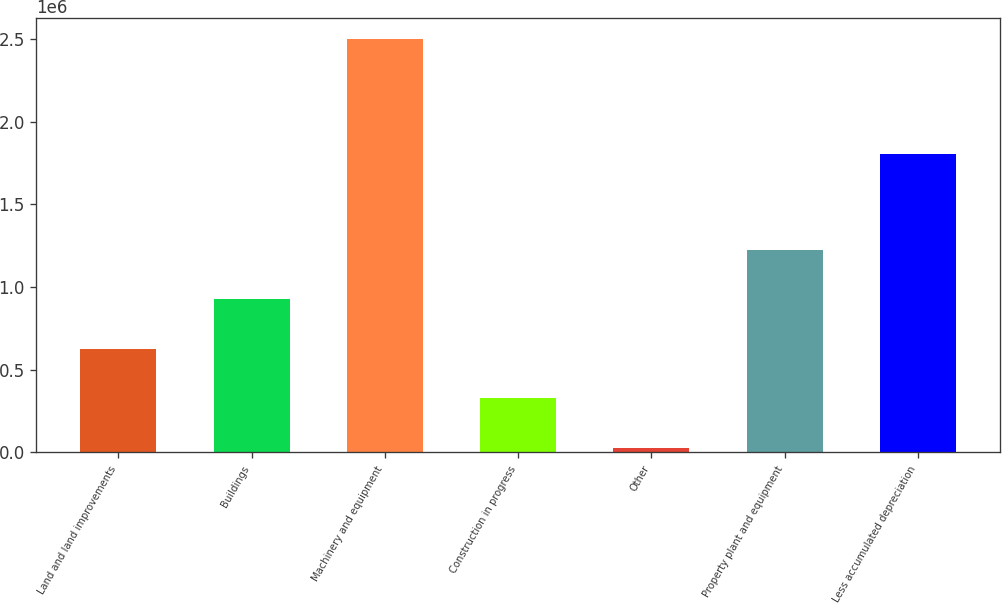Convert chart. <chart><loc_0><loc_0><loc_500><loc_500><bar_chart><fcel>Land and land improvements<fcel>Buildings<fcel>Machinery and equipment<fcel>Construction in progress<fcel>Other<fcel>Property plant and equipment<fcel>Less accumulated depreciation<nl><fcel>627211<fcel>926327<fcel>2.50029e+06<fcel>328096<fcel>28980<fcel>1.22544e+06<fcel>1.80484e+06<nl></chart> 